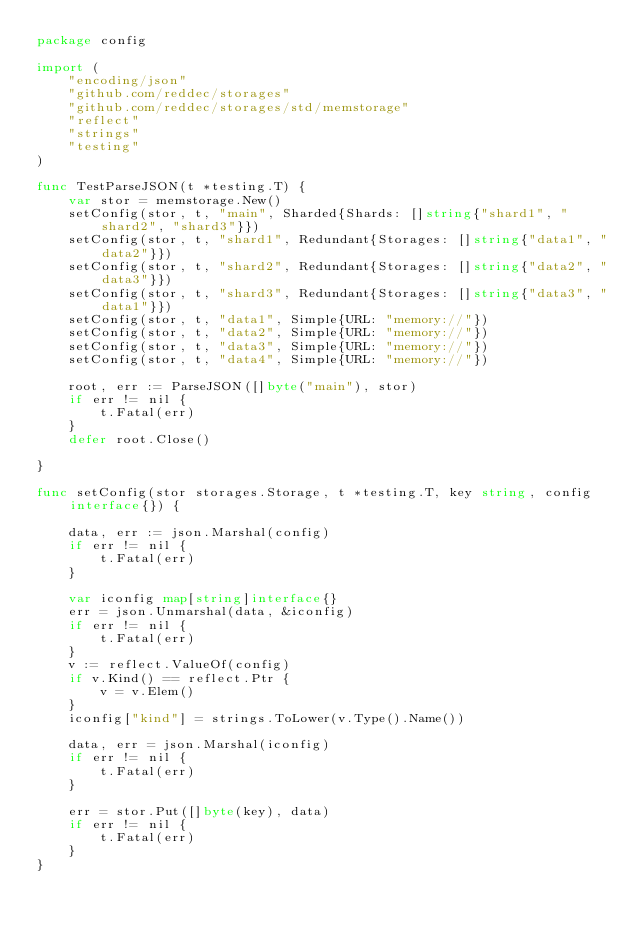<code> <loc_0><loc_0><loc_500><loc_500><_Go_>package config

import (
	"encoding/json"
	"github.com/reddec/storages"
	"github.com/reddec/storages/std/memstorage"
	"reflect"
	"strings"
	"testing"
)

func TestParseJSON(t *testing.T) {
	var stor = memstorage.New()
	setConfig(stor, t, "main", Sharded{Shards: []string{"shard1", "shard2", "shard3"}})
	setConfig(stor, t, "shard1", Redundant{Storages: []string{"data1", "data2"}})
	setConfig(stor, t, "shard2", Redundant{Storages: []string{"data2", "data3"}})
	setConfig(stor, t, "shard3", Redundant{Storages: []string{"data3", "data1"}})
	setConfig(stor, t, "data1", Simple{URL: "memory://"})
	setConfig(stor, t, "data2", Simple{URL: "memory://"})
	setConfig(stor, t, "data3", Simple{URL: "memory://"})
	setConfig(stor, t, "data4", Simple{URL: "memory://"})

	root, err := ParseJSON([]byte("main"), stor)
	if err != nil {
		t.Fatal(err)
	}
	defer root.Close()

}

func setConfig(stor storages.Storage, t *testing.T, key string, config interface{}) {

	data, err := json.Marshal(config)
	if err != nil {
		t.Fatal(err)
	}

	var iconfig map[string]interface{}
	err = json.Unmarshal(data, &iconfig)
	if err != nil {
		t.Fatal(err)
	}
	v := reflect.ValueOf(config)
	if v.Kind() == reflect.Ptr {
		v = v.Elem()
	}
	iconfig["kind"] = strings.ToLower(v.Type().Name())

	data, err = json.Marshal(iconfig)
	if err != nil {
		t.Fatal(err)
	}

	err = stor.Put([]byte(key), data)
	if err != nil {
		t.Fatal(err)
	}
}
</code> 